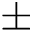<formula> <loc_0><loc_0><loc_500><loc_500>\pm</formula> 